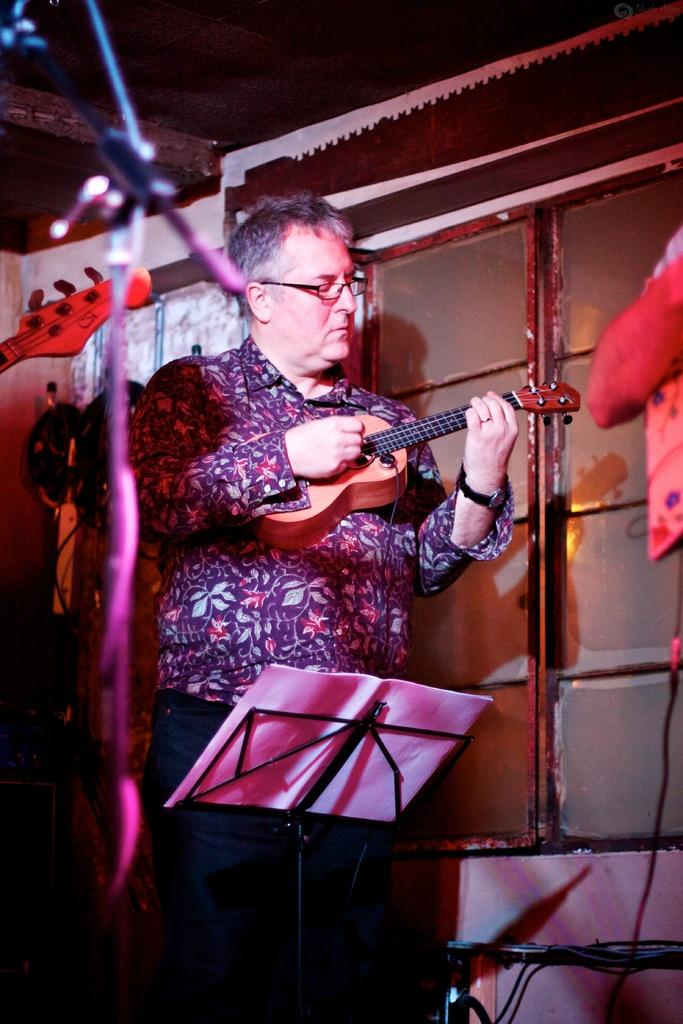What is the main subject of the image? The main subject of the image is a man. Can you describe the man's position in the image? The man is standing in the center of the image. What is the man holding in his hand? The man is holding a guitar in his hand. What type of action is the man taking in the image? The image does not depict the man taking any specific action, as he is simply standing and holding a guitar. Is this image an advertisement for a product or service? There is no indication in the image that it is an advertisement for a product or service. 